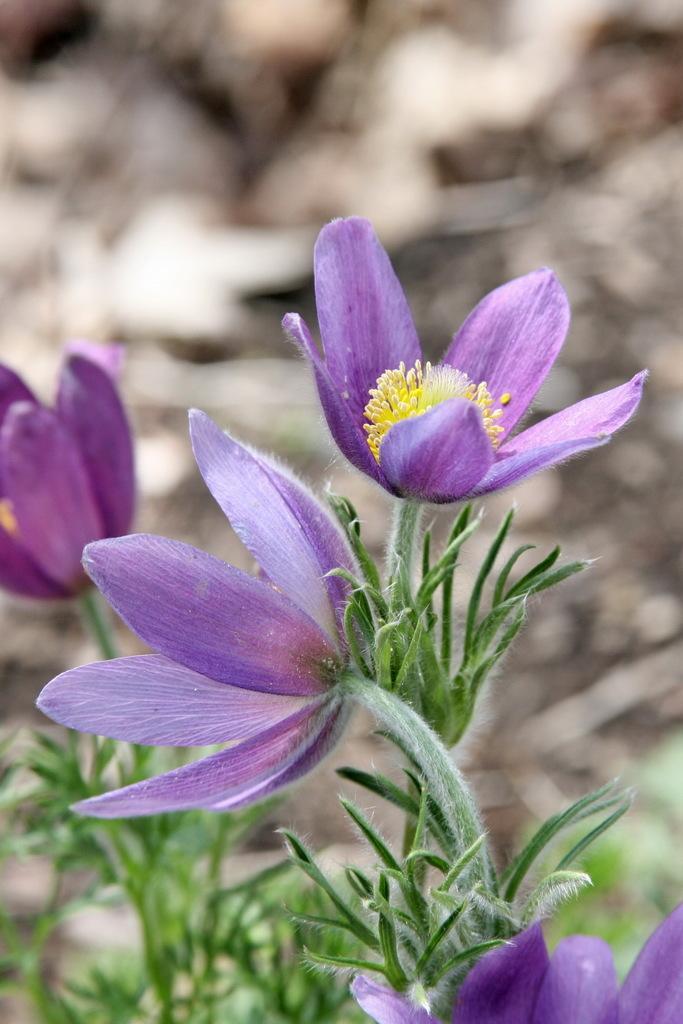Please provide a concise description of this image. In this picture I can observe violet color flowers to the plants. The background is completely blurred. 